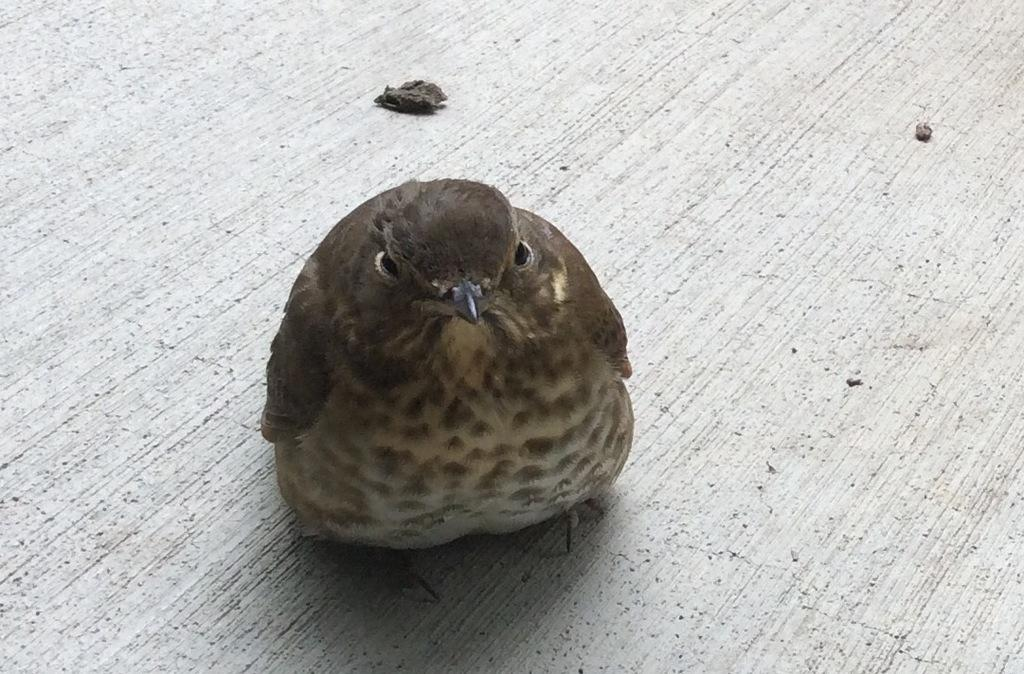What is the main subject in the center of the image? There is a bird in the center of the image. Where is the bird located in the image? The bird is on the floor. What type of thread is the bird using to sew in the image? There is no thread or sewing activity present in the image. What type of alley can be seen in the background of the image? There is no alley visible in the image; it features a bird on the floor. 